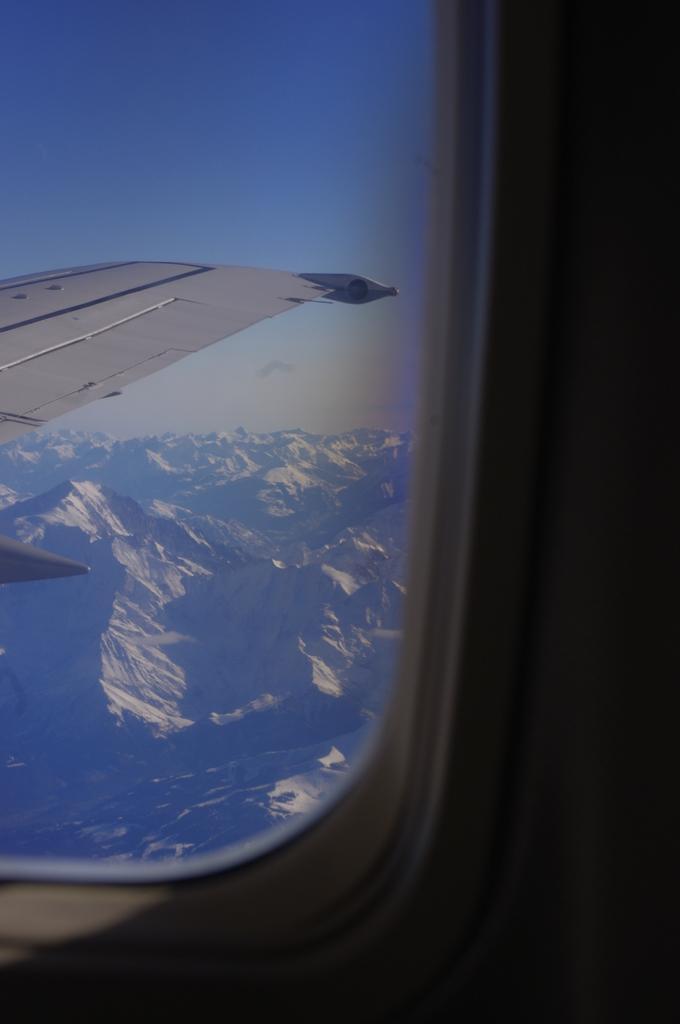Could you give a brief overview of what you see in this image? In this image we can see inside of the aircraft. There is a part of the aircraft in the image. There are many mountains in the image. There is a sky in the image. 